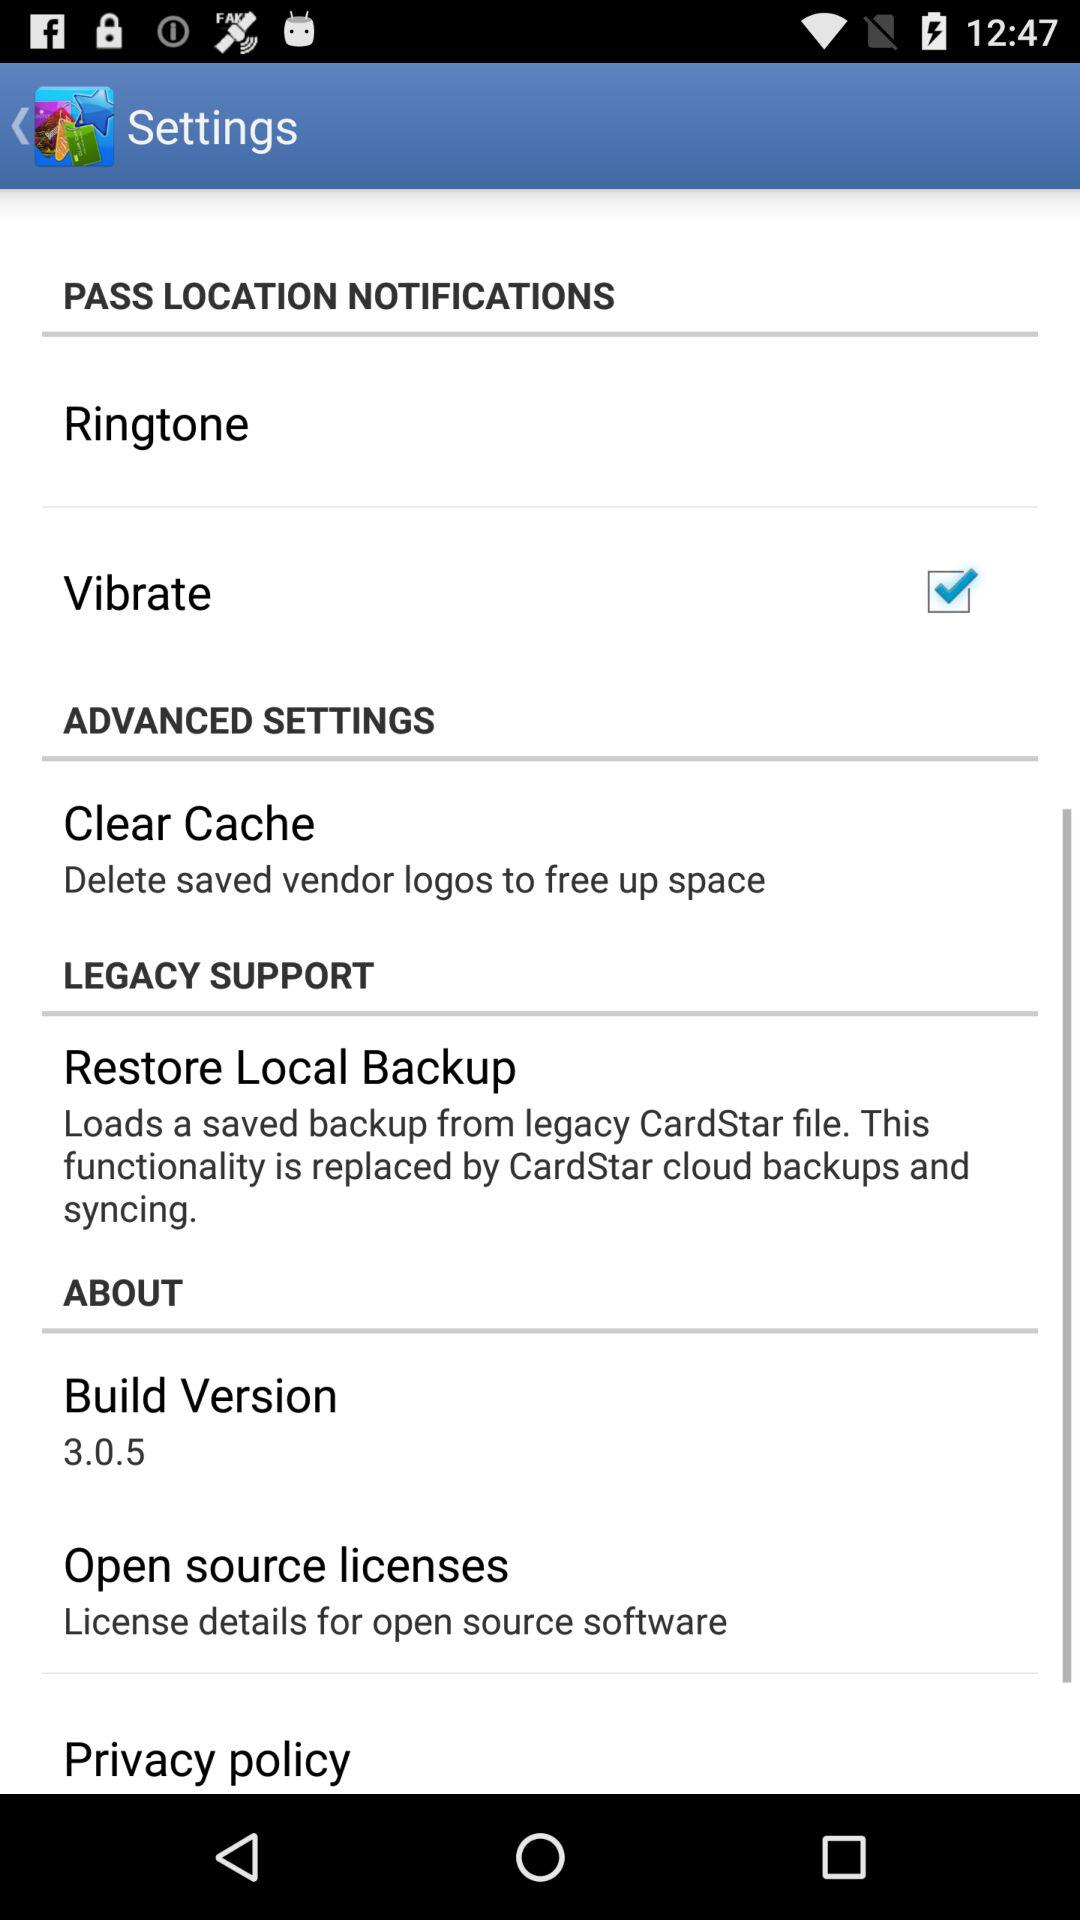What is the build version? The build version is 3.0.5. 